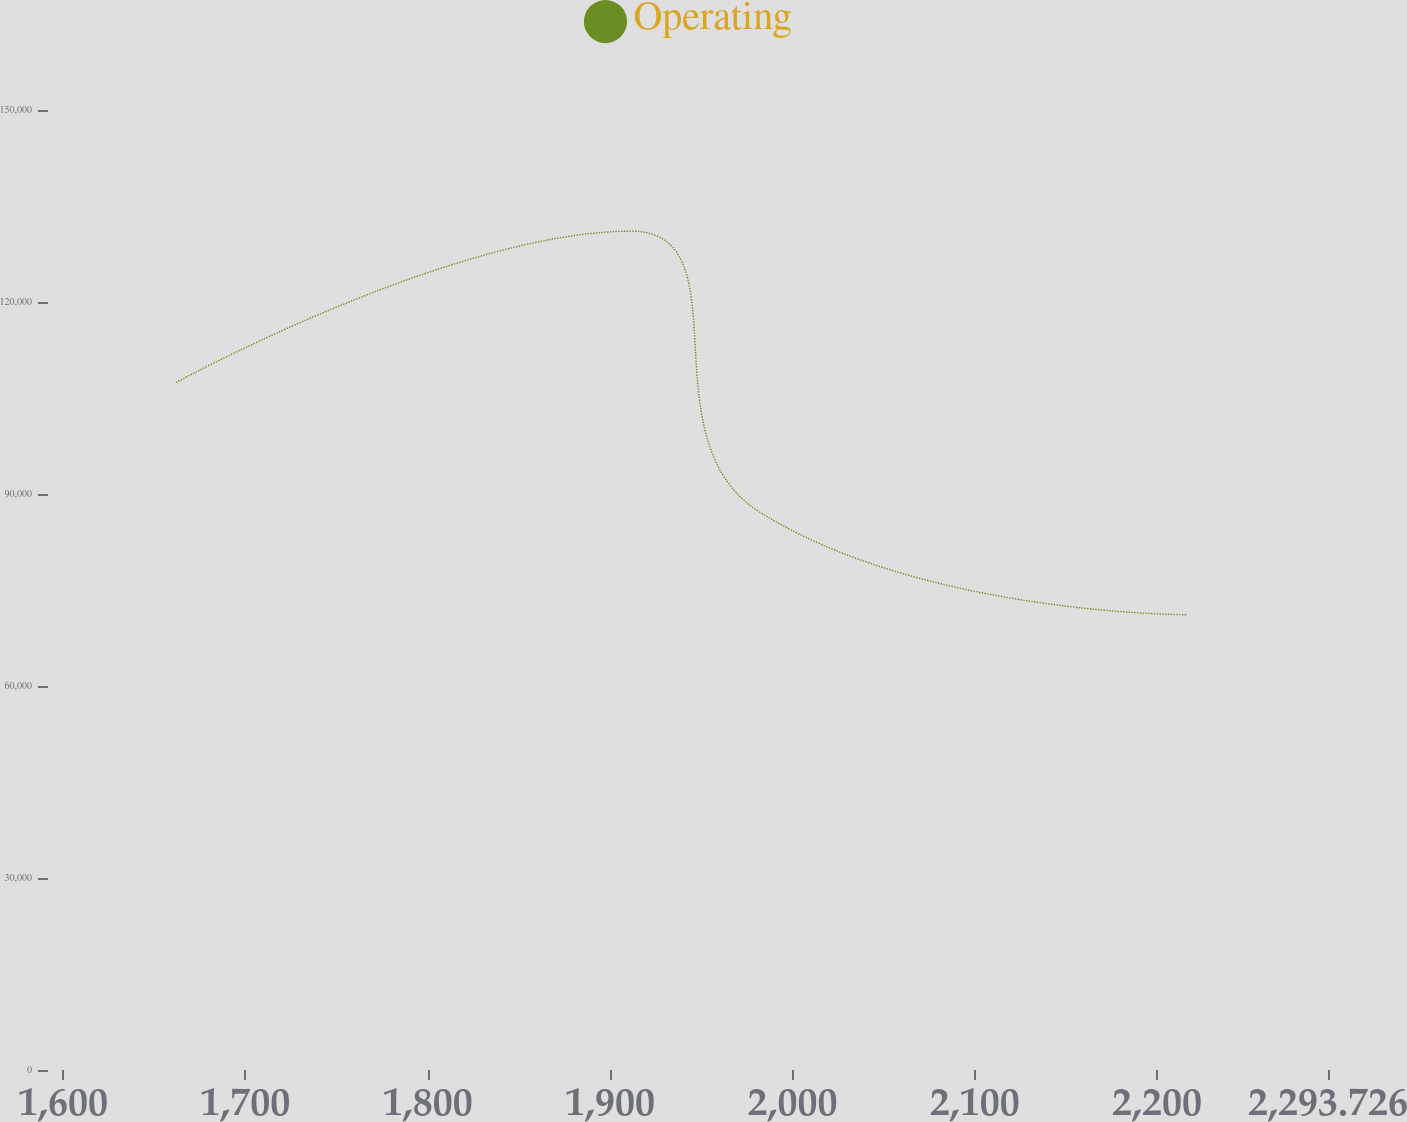Convert chart. <chart><loc_0><loc_0><loc_500><loc_500><line_chart><ecel><fcel>Operating<nl><fcel>1661.98<fcel>107409<nl><fcel>1911.63<fcel>131068<nl><fcel>1981.82<fcel>87221.6<nl><fcel>2216.61<fcel>71133<nl><fcel>2363.92<fcel>77126.5<nl></chart> 